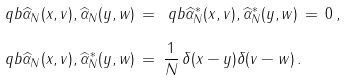<formula> <loc_0><loc_0><loc_500><loc_500>\ q b { \widehat { \alpha } _ { N } ( x , v ) , \widehat { \alpha } _ { N } ( y , w ) } & \, = \, \ q b { \widehat { \alpha } _ { N } ^ { * } ( x , v ) , \widehat { \alpha } _ { N } ^ { * } ( y , w ) } \, = \, 0 \, , \\ \ q b { \widehat { \alpha } _ { N } ( x , v ) , \widehat { \alpha } _ { N } ^ { * } ( y , w ) } & \, = \, \frac { 1 } { N } \, \delta ( x - y ) \delta ( v - w ) \, .</formula> 